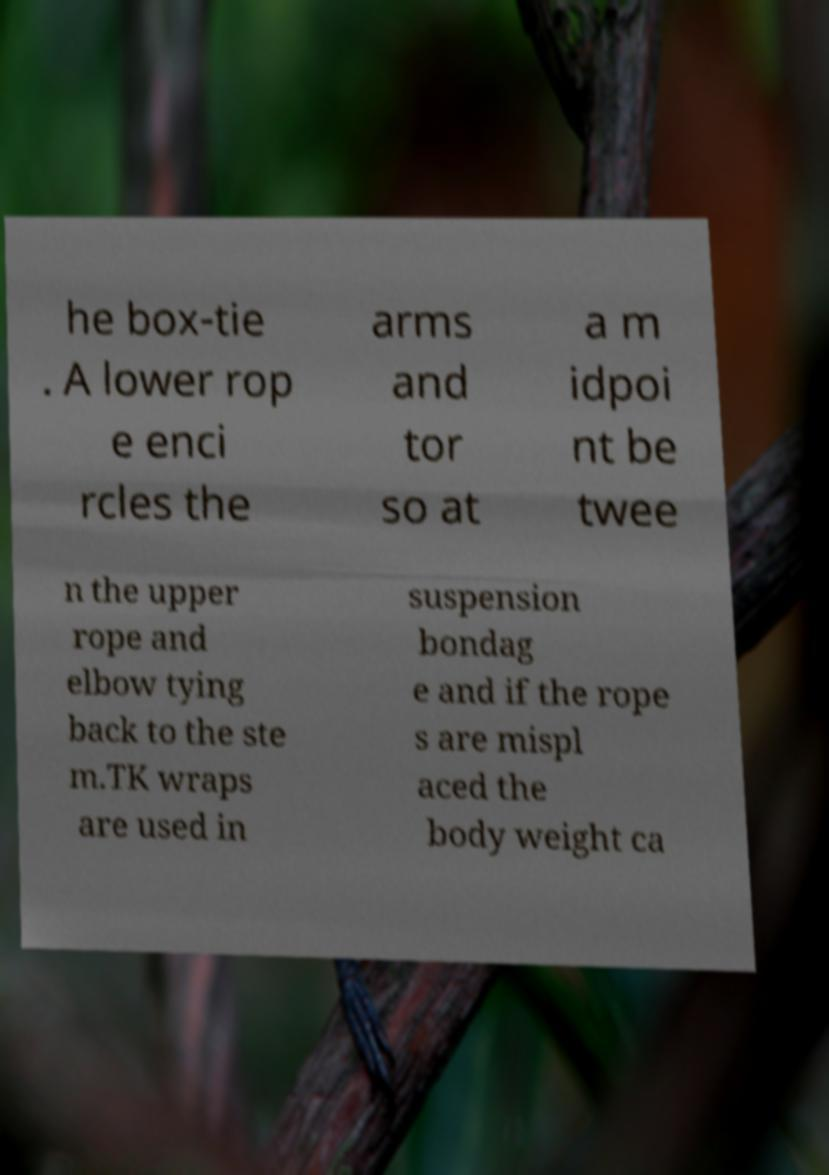For documentation purposes, I need the text within this image transcribed. Could you provide that? he box-tie . A lower rop e enci rcles the arms and tor so at a m idpoi nt be twee n the upper rope and elbow tying back to the ste m.TK wraps are used in suspension bondag e and if the rope s are mispl aced the body weight ca 